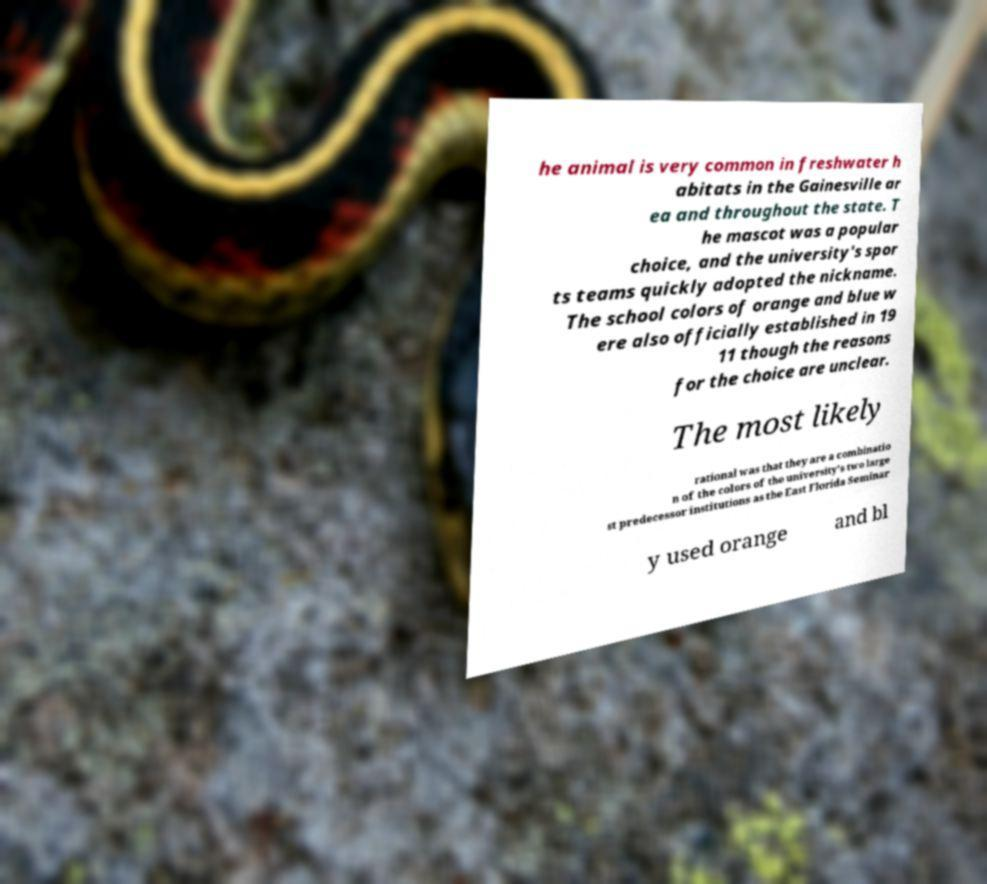There's text embedded in this image that I need extracted. Can you transcribe it verbatim? he animal is very common in freshwater h abitats in the Gainesville ar ea and throughout the state. T he mascot was a popular choice, and the university's spor ts teams quickly adopted the nickname. The school colors of orange and blue w ere also officially established in 19 11 though the reasons for the choice are unclear. The most likely rational was that they are a combinatio n of the colors of the university's two large st predecessor institutions as the East Florida Seminar y used orange and bl 